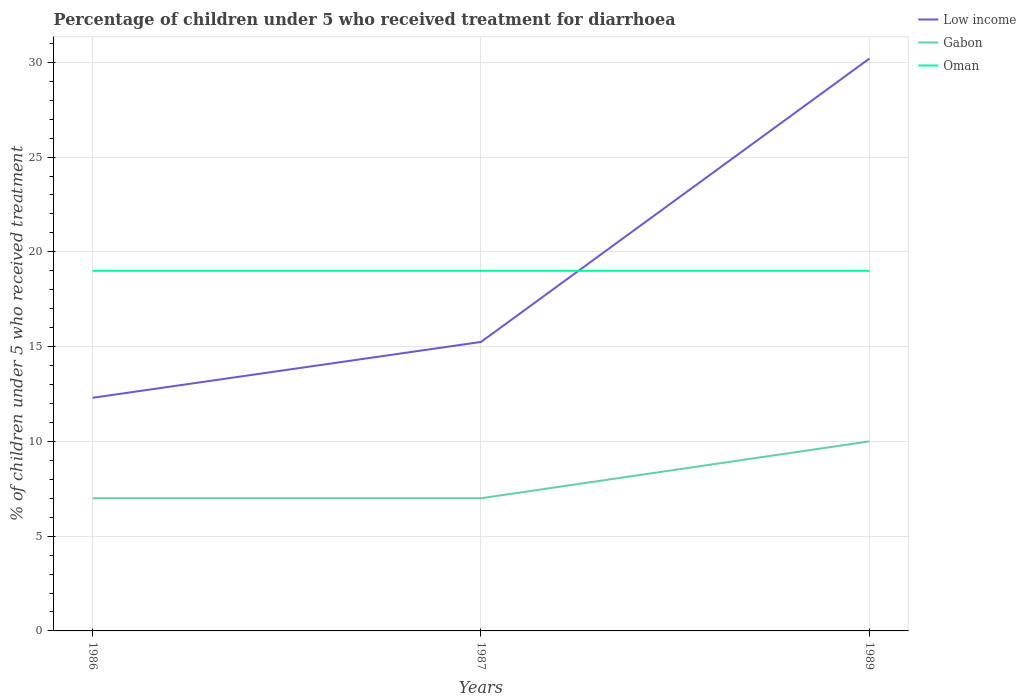How many different coloured lines are there?
Make the answer very short. 3. Is the number of lines equal to the number of legend labels?
Offer a terse response. Yes. What is the difference between the highest and the second highest percentage of children who received treatment for diarrhoea  in Low income?
Provide a short and direct response. 17.9. What is the difference between the highest and the lowest percentage of children who received treatment for diarrhoea  in Oman?
Provide a succinct answer. 0. How many lines are there?
Keep it short and to the point. 3. Are the values on the major ticks of Y-axis written in scientific E-notation?
Keep it short and to the point. No. Does the graph contain any zero values?
Make the answer very short. No. Does the graph contain grids?
Your response must be concise. Yes. Where does the legend appear in the graph?
Your response must be concise. Top right. What is the title of the graph?
Keep it short and to the point. Percentage of children under 5 who received treatment for diarrhoea. Does "Senegal" appear as one of the legend labels in the graph?
Provide a succinct answer. No. What is the label or title of the Y-axis?
Make the answer very short. % of children under 5 who received treatment. What is the % of children under 5 who received treatment of Low income in 1986?
Offer a terse response. 12.3. What is the % of children under 5 who received treatment of Low income in 1987?
Provide a short and direct response. 15.25. What is the % of children under 5 who received treatment of Gabon in 1987?
Make the answer very short. 7. What is the % of children under 5 who received treatment in Low income in 1989?
Offer a very short reply. 30.2. What is the % of children under 5 who received treatment in Oman in 1989?
Give a very brief answer. 19. Across all years, what is the maximum % of children under 5 who received treatment in Low income?
Ensure brevity in your answer.  30.2. Across all years, what is the minimum % of children under 5 who received treatment of Low income?
Offer a terse response. 12.3. Across all years, what is the minimum % of children under 5 who received treatment of Gabon?
Provide a short and direct response. 7. What is the total % of children under 5 who received treatment of Low income in the graph?
Provide a succinct answer. 57.74. What is the difference between the % of children under 5 who received treatment in Low income in 1986 and that in 1987?
Provide a succinct answer. -2.95. What is the difference between the % of children under 5 who received treatment in Gabon in 1986 and that in 1987?
Offer a very short reply. 0. What is the difference between the % of children under 5 who received treatment of Low income in 1986 and that in 1989?
Your answer should be very brief. -17.9. What is the difference between the % of children under 5 who received treatment in Gabon in 1986 and that in 1989?
Provide a short and direct response. -3. What is the difference between the % of children under 5 who received treatment of Oman in 1986 and that in 1989?
Your response must be concise. 0. What is the difference between the % of children under 5 who received treatment of Low income in 1987 and that in 1989?
Offer a very short reply. -14.95. What is the difference between the % of children under 5 who received treatment of Gabon in 1987 and that in 1989?
Your answer should be compact. -3. What is the difference between the % of children under 5 who received treatment in Low income in 1986 and the % of children under 5 who received treatment in Gabon in 1987?
Ensure brevity in your answer.  5.3. What is the difference between the % of children under 5 who received treatment of Low income in 1986 and the % of children under 5 who received treatment of Oman in 1987?
Your answer should be compact. -6.7. What is the difference between the % of children under 5 who received treatment in Low income in 1986 and the % of children under 5 who received treatment in Gabon in 1989?
Your response must be concise. 2.3. What is the difference between the % of children under 5 who received treatment of Low income in 1986 and the % of children under 5 who received treatment of Oman in 1989?
Give a very brief answer. -6.7. What is the difference between the % of children under 5 who received treatment of Gabon in 1986 and the % of children under 5 who received treatment of Oman in 1989?
Provide a succinct answer. -12. What is the difference between the % of children under 5 who received treatment in Low income in 1987 and the % of children under 5 who received treatment in Gabon in 1989?
Offer a very short reply. 5.25. What is the difference between the % of children under 5 who received treatment in Low income in 1987 and the % of children under 5 who received treatment in Oman in 1989?
Make the answer very short. -3.75. What is the difference between the % of children under 5 who received treatment in Gabon in 1987 and the % of children under 5 who received treatment in Oman in 1989?
Your answer should be compact. -12. What is the average % of children under 5 who received treatment in Low income per year?
Provide a short and direct response. 19.25. What is the average % of children under 5 who received treatment in Oman per year?
Ensure brevity in your answer.  19. In the year 1986, what is the difference between the % of children under 5 who received treatment of Low income and % of children under 5 who received treatment of Gabon?
Make the answer very short. 5.3. In the year 1986, what is the difference between the % of children under 5 who received treatment of Low income and % of children under 5 who received treatment of Oman?
Ensure brevity in your answer.  -6.7. In the year 1987, what is the difference between the % of children under 5 who received treatment in Low income and % of children under 5 who received treatment in Gabon?
Give a very brief answer. 8.25. In the year 1987, what is the difference between the % of children under 5 who received treatment in Low income and % of children under 5 who received treatment in Oman?
Ensure brevity in your answer.  -3.75. In the year 1987, what is the difference between the % of children under 5 who received treatment of Gabon and % of children under 5 who received treatment of Oman?
Your answer should be very brief. -12. In the year 1989, what is the difference between the % of children under 5 who received treatment in Low income and % of children under 5 who received treatment in Gabon?
Your answer should be compact. 20.2. In the year 1989, what is the difference between the % of children under 5 who received treatment of Low income and % of children under 5 who received treatment of Oman?
Offer a terse response. 11.2. What is the ratio of the % of children under 5 who received treatment of Low income in 1986 to that in 1987?
Your response must be concise. 0.81. What is the ratio of the % of children under 5 who received treatment in Oman in 1986 to that in 1987?
Offer a terse response. 1. What is the ratio of the % of children under 5 who received treatment of Low income in 1986 to that in 1989?
Your answer should be compact. 0.41. What is the ratio of the % of children under 5 who received treatment in Oman in 1986 to that in 1989?
Your response must be concise. 1. What is the ratio of the % of children under 5 who received treatment of Low income in 1987 to that in 1989?
Offer a very short reply. 0.5. What is the ratio of the % of children under 5 who received treatment in Oman in 1987 to that in 1989?
Ensure brevity in your answer.  1. What is the difference between the highest and the second highest % of children under 5 who received treatment of Low income?
Your response must be concise. 14.95. What is the difference between the highest and the lowest % of children under 5 who received treatment of Low income?
Keep it short and to the point. 17.9. What is the difference between the highest and the lowest % of children under 5 who received treatment in Gabon?
Your answer should be very brief. 3. What is the difference between the highest and the lowest % of children under 5 who received treatment in Oman?
Ensure brevity in your answer.  0. 